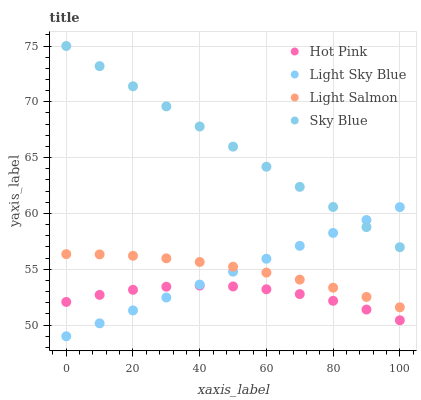Does Hot Pink have the minimum area under the curve?
Answer yes or no. Yes. Does Sky Blue have the maximum area under the curve?
Answer yes or no. Yes. Does Light Salmon have the minimum area under the curve?
Answer yes or no. No. Does Light Salmon have the maximum area under the curve?
Answer yes or no. No. Is Light Sky Blue the smoothest?
Answer yes or no. Yes. Is Hot Pink the roughest?
Answer yes or no. Yes. Is Light Salmon the smoothest?
Answer yes or no. No. Is Light Salmon the roughest?
Answer yes or no. No. Does Light Sky Blue have the lowest value?
Answer yes or no. Yes. Does Light Salmon have the lowest value?
Answer yes or no. No. Does Sky Blue have the highest value?
Answer yes or no. Yes. Does Light Salmon have the highest value?
Answer yes or no. No. Is Hot Pink less than Sky Blue?
Answer yes or no. Yes. Is Sky Blue greater than Light Salmon?
Answer yes or no. Yes. Does Light Salmon intersect Light Sky Blue?
Answer yes or no. Yes. Is Light Salmon less than Light Sky Blue?
Answer yes or no. No. Is Light Salmon greater than Light Sky Blue?
Answer yes or no. No. Does Hot Pink intersect Sky Blue?
Answer yes or no. No. 